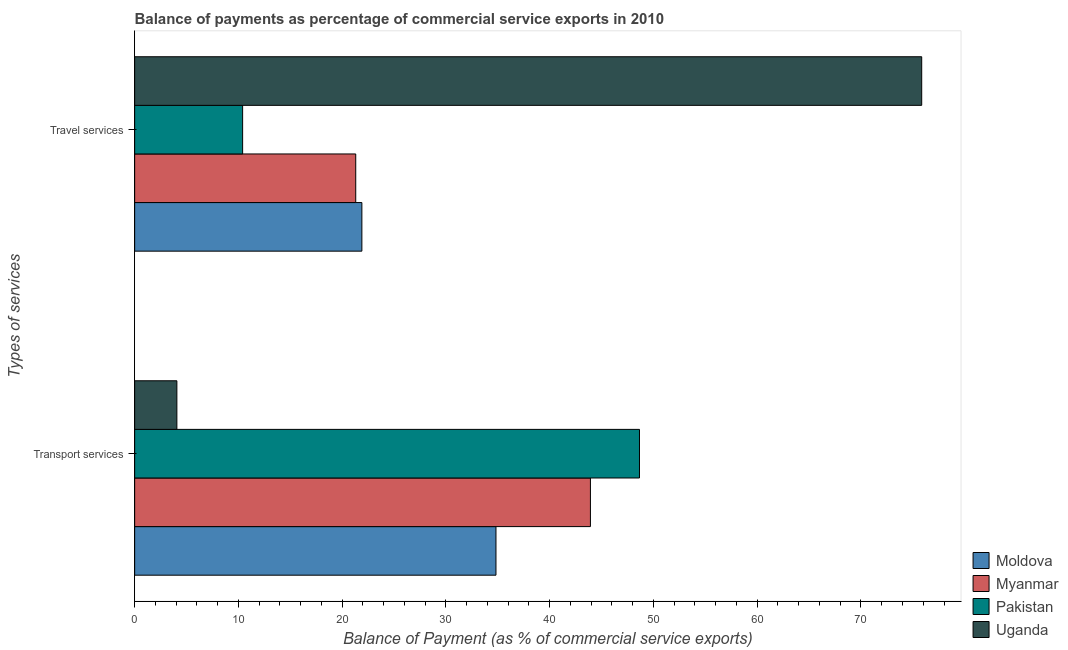Are the number of bars per tick equal to the number of legend labels?
Your answer should be very brief. Yes. Are the number of bars on each tick of the Y-axis equal?
Keep it short and to the point. Yes. What is the label of the 1st group of bars from the top?
Ensure brevity in your answer.  Travel services. What is the balance of payments of travel services in Pakistan?
Keep it short and to the point. 10.41. Across all countries, what is the maximum balance of payments of transport services?
Give a very brief answer. 48.65. Across all countries, what is the minimum balance of payments of transport services?
Give a very brief answer. 4.07. In which country was the balance of payments of travel services maximum?
Your response must be concise. Uganda. In which country was the balance of payments of transport services minimum?
Keep it short and to the point. Uganda. What is the total balance of payments of transport services in the graph?
Make the answer very short. 131.47. What is the difference between the balance of payments of travel services in Pakistan and that in Uganda?
Ensure brevity in your answer.  -65.45. What is the difference between the balance of payments of travel services in Moldova and the balance of payments of transport services in Myanmar?
Offer a terse response. -22.03. What is the average balance of payments of travel services per country?
Offer a very short reply. 32.37. What is the difference between the balance of payments of transport services and balance of payments of travel services in Moldova?
Offer a very short reply. 12.92. What is the ratio of the balance of payments of transport services in Myanmar to that in Moldova?
Provide a short and direct response. 1.26. What does the 1st bar from the bottom in Transport services represents?
Offer a very short reply. Moldova. Are all the bars in the graph horizontal?
Your answer should be compact. Yes. What is the difference between two consecutive major ticks on the X-axis?
Your answer should be very brief. 10. Are the values on the major ticks of X-axis written in scientific E-notation?
Your answer should be very brief. No. Does the graph contain grids?
Make the answer very short. No. Where does the legend appear in the graph?
Your answer should be compact. Bottom right. What is the title of the graph?
Offer a very short reply. Balance of payments as percentage of commercial service exports in 2010. Does "Botswana" appear as one of the legend labels in the graph?
Your answer should be compact. No. What is the label or title of the X-axis?
Your response must be concise. Balance of Payment (as % of commercial service exports). What is the label or title of the Y-axis?
Ensure brevity in your answer.  Types of services. What is the Balance of Payment (as % of commercial service exports) in Moldova in Transport services?
Offer a very short reply. 34.82. What is the Balance of Payment (as % of commercial service exports) in Myanmar in Transport services?
Your response must be concise. 43.93. What is the Balance of Payment (as % of commercial service exports) in Pakistan in Transport services?
Offer a terse response. 48.65. What is the Balance of Payment (as % of commercial service exports) in Uganda in Transport services?
Offer a terse response. 4.07. What is the Balance of Payment (as % of commercial service exports) in Moldova in Travel services?
Provide a short and direct response. 21.9. What is the Balance of Payment (as % of commercial service exports) in Myanmar in Travel services?
Provide a short and direct response. 21.31. What is the Balance of Payment (as % of commercial service exports) in Pakistan in Travel services?
Your answer should be compact. 10.41. What is the Balance of Payment (as % of commercial service exports) in Uganda in Travel services?
Give a very brief answer. 75.85. Across all Types of services, what is the maximum Balance of Payment (as % of commercial service exports) of Moldova?
Your response must be concise. 34.82. Across all Types of services, what is the maximum Balance of Payment (as % of commercial service exports) of Myanmar?
Offer a very short reply. 43.93. Across all Types of services, what is the maximum Balance of Payment (as % of commercial service exports) of Pakistan?
Provide a succinct answer. 48.65. Across all Types of services, what is the maximum Balance of Payment (as % of commercial service exports) in Uganda?
Keep it short and to the point. 75.85. Across all Types of services, what is the minimum Balance of Payment (as % of commercial service exports) of Moldova?
Ensure brevity in your answer.  21.9. Across all Types of services, what is the minimum Balance of Payment (as % of commercial service exports) in Myanmar?
Provide a short and direct response. 21.31. Across all Types of services, what is the minimum Balance of Payment (as % of commercial service exports) of Pakistan?
Offer a terse response. 10.41. Across all Types of services, what is the minimum Balance of Payment (as % of commercial service exports) of Uganda?
Provide a short and direct response. 4.07. What is the total Balance of Payment (as % of commercial service exports) of Moldova in the graph?
Your answer should be very brief. 56.72. What is the total Balance of Payment (as % of commercial service exports) in Myanmar in the graph?
Make the answer very short. 65.23. What is the total Balance of Payment (as % of commercial service exports) of Pakistan in the graph?
Give a very brief answer. 59.06. What is the total Balance of Payment (as % of commercial service exports) of Uganda in the graph?
Offer a very short reply. 79.92. What is the difference between the Balance of Payment (as % of commercial service exports) of Moldova in Transport services and that in Travel services?
Your response must be concise. 12.92. What is the difference between the Balance of Payment (as % of commercial service exports) in Myanmar in Transport services and that in Travel services?
Offer a very short reply. 22.62. What is the difference between the Balance of Payment (as % of commercial service exports) in Pakistan in Transport services and that in Travel services?
Your answer should be very brief. 38.25. What is the difference between the Balance of Payment (as % of commercial service exports) of Uganda in Transport services and that in Travel services?
Your response must be concise. -71.78. What is the difference between the Balance of Payment (as % of commercial service exports) in Moldova in Transport services and the Balance of Payment (as % of commercial service exports) in Myanmar in Travel services?
Provide a short and direct response. 13.51. What is the difference between the Balance of Payment (as % of commercial service exports) in Moldova in Transport services and the Balance of Payment (as % of commercial service exports) in Pakistan in Travel services?
Your answer should be very brief. 24.42. What is the difference between the Balance of Payment (as % of commercial service exports) of Moldova in Transport services and the Balance of Payment (as % of commercial service exports) of Uganda in Travel services?
Keep it short and to the point. -41.03. What is the difference between the Balance of Payment (as % of commercial service exports) of Myanmar in Transport services and the Balance of Payment (as % of commercial service exports) of Pakistan in Travel services?
Your answer should be very brief. 33.52. What is the difference between the Balance of Payment (as % of commercial service exports) in Myanmar in Transport services and the Balance of Payment (as % of commercial service exports) in Uganda in Travel services?
Keep it short and to the point. -31.93. What is the difference between the Balance of Payment (as % of commercial service exports) in Pakistan in Transport services and the Balance of Payment (as % of commercial service exports) in Uganda in Travel services?
Give a very brief answer. -27.2. What is the average Balance of Payment (as % of commercial service exports) in Moldova per Types of services?
Your response must be concise. 28.36. What is the average Balance of Payment (as % of commercial service exports) of Myanmar per Types of services?
Your answer should be compact. 32.62. What is the average Balance of Payment (as % of commercial service exports) of Pakistan per Types of services?
Give a very brief answer. 29.53. What is the average Balance of Payment (as % of commercial service exports) in Uganda per Types of services?
Provide a succinct answer. 39.96. What is the difference between the Balance of Payment (as % of commercial service exports) in Moldova and Balance of Payment (as % of commercial service exports) in Myanmar in Transport services?
Provide a succinct answer. -9.1. What is the difference between the Balance of Payment (as % of commercial service exports) of Moldova and Balance of Payment (as % of commercial service exports) of Pakistan in Transport services?
Your answer should be compact. -13.83. What is the difference between the Balance of Payment (as % of commercial service exports) of Moldova and Balance of Payment (as % of commercial service exports) of Uganda in Transport services?
Give a very brief answer. 30.75. What is the difference between the Balance of Payment (as % of commercial service exports) of Myanmar and Balance of Payment (as % of commercial service exports) of Pakistan in Transport services?
Your answer should be compact. -4.73. What is the difference between the Balance of Payment (as % of commercial service exports) of Myanmar and Balance of Payment (as % of commercial service exports) of Uganda in Transport services?
Your response must be concise. 39.86. What is the difference between the Balance of Payment (as % of commercial service exports) in Pakistan and Balance of Payment (as % of commercial service exports) in Uganda in Transport services?
Your response must be concise. 44.58. What is the difference between the Balance of Payment (as % of commercial service exports) of Moldova and Balance of Payment (as % of commercial service exports) of Myanmar in Travel services?
Your answer should be compact. 0.59. What is the difference between the Balance of Payment (as % of commercial service exports) in Moldova and Balance of Payment (as % of commercial service exports) in Pakistan in Travel services?
Your answer should be compact. 11.49. What is the difference between the Balance of Payment (as % of commercial service exports) in Moldova and Balance of Payment (as % of commercial service exports) in Uganda in Travel services?
Keep it short and to the point. -53.95. What is the difference between the Balance of Payment (as % of commercial service exports) of Myanmar and Balance of Payment (as % of commercial service exports) of Pakistan in Travel services?
Your response must be concise. 10.9. What is the difference between the Balance of Payment (as % of commercial service exports) in Myanmar and Balance of Payment (as % of commercial service exports) in Uganda in Travel services?
Keep it short and to the point. -54.54. What is the difference between the Balance of Payment (as % of commercial service exports) in Pakistan and Balance of Payment (as % of commercial service exports) in Uganda in Travel services?
Offer a terse response. -65.45. What is the ratio of the Balance of Payment (as % of commercial service exports) in Moldova in Transport services to that in Travel services?
Make the answer very short. 1.59. What is the ratio of the Balance of Payment (as % of commercial service exports) of Myanmar in Transport services to that in Travel services?
Your answer should be very brief. 2.06. What is the ratio of the Balance of Payment (as % of commercial service exports) of Pakistan in Transport services to that in Travel services?
Ensure brevity in your answer.  4.68. What is the ratio of the Balance of Payment (as % of commercial service exports) in Uganda in Transport services to that in Travel services?
Your answer should be very brief. 0.05. What is the difference between the highest and the second highest Balance of Payment (as % of commercial service exports) in Moldova?
Offer a very short reply. 12.92. What is the difference between the highest and the second highest Balance of Payment (as % of commercial service exports) in Myanmar?
Keep it short and to the point. 22.62. What is the difference between the highest and the second highest Balance of Payment (as % of commercial service exports) in Pakistan?
Your response must be concise. 38.25. What is the difference between the highest and the second highest Balance of Payment (as % of commercial service exports) in Uganda?
Provide a succinct answer. 71.78. What is the difference between the highest and the lowest Balance of Payment (as % of commercial service exports) of Moldova?
Ensure brevity in your answer.  12.92. What is the difference between the highest and the lowest Balance of Payment (as % of commercial service exports) of Myanmar?
Offer a very short reply. 22.62. What is the difference between the highest and the lowest Balance of Payment (as % of commercial service exports) of Pakistan?
Keep it short and to the point. 38.25. What is the difference between the highest and the lowest Balance of Payment (as % of commercial service exports) of Uganda?
Your answer should be compact. 71.78. 